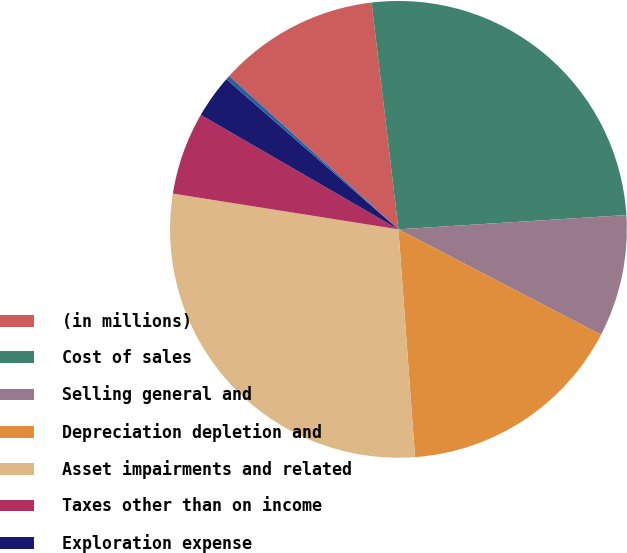<chart> <loc_0><loc_0><loc_500><loc_500><pie_chart><fcel>(in millions)<fcel>Cost of sales<fcel>Selling general and<fcel>Depreciation depletion and<fcel>Asset impairments and related<fcel>Taxes other than on income<fcel>Exploration expense<fcel>Interest and debt expense net<nl><fcel>11.41%<fcel>25.88%<fcel>8.63%<fcel>16.21%<fcel>28.66%<fcel>5.85%<fcel>3.07%<fcel>0.29%<nl></chart> 